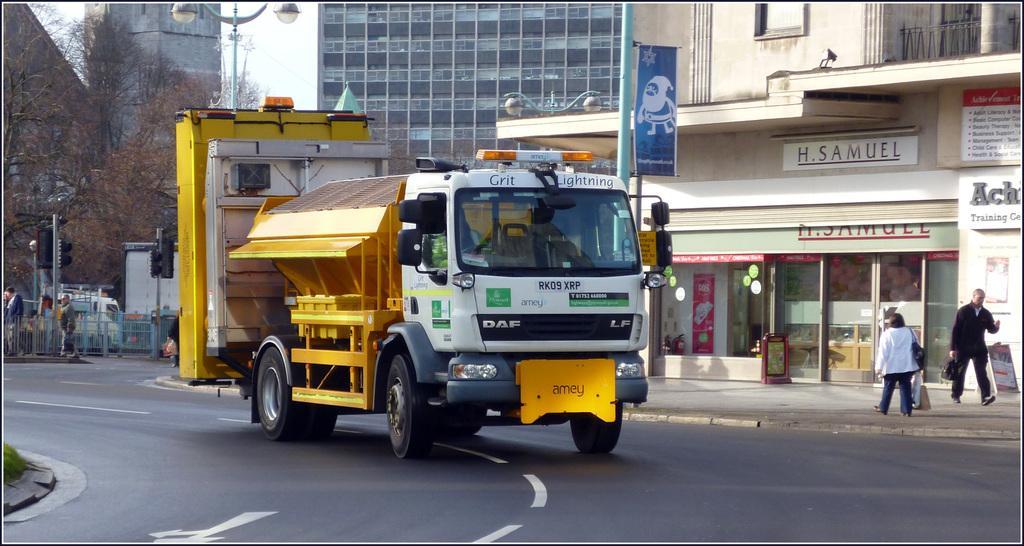Please provide a concise description of this image. In this image there is a truck on the road beside that there are buildings, trees, traffic lights and some other poles, also people walking on pavement. 